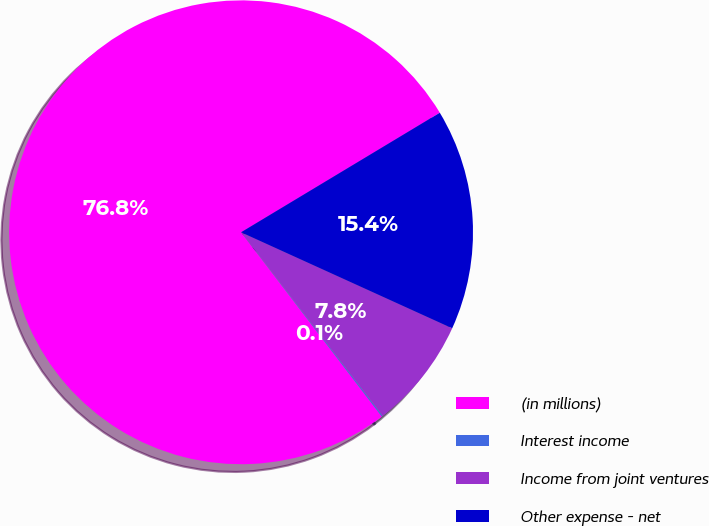Convert chart to OTSL. <chart><loc_0><loc_0><loc_500><loc_500><pie_chart><fcel>(in millions)<fcel>Interest income<fcel>Income from joint ventures<fcel>Other expense - net<nl><fcel>76.76%<fcel>0.08%<fcel>7.75%<fcel>15.41%<nl></chart> 